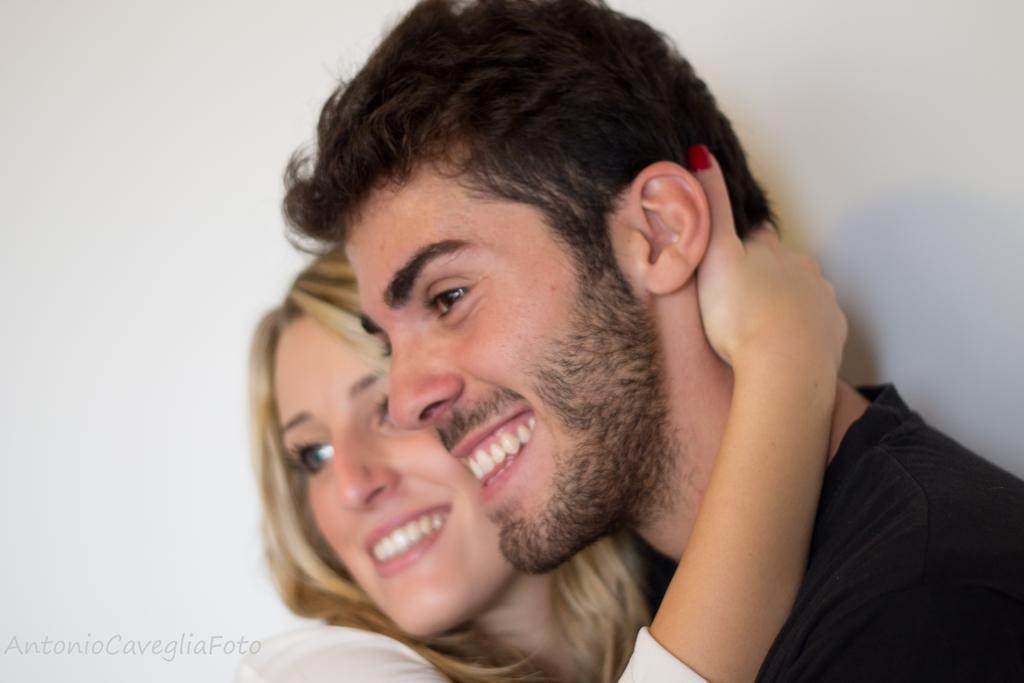Can you describe this image briefly? In the center of the image we can see two people are smiling, which we can see on their faces. At the bottom left side of the image, there is a watermark. In the background there is a wall. 